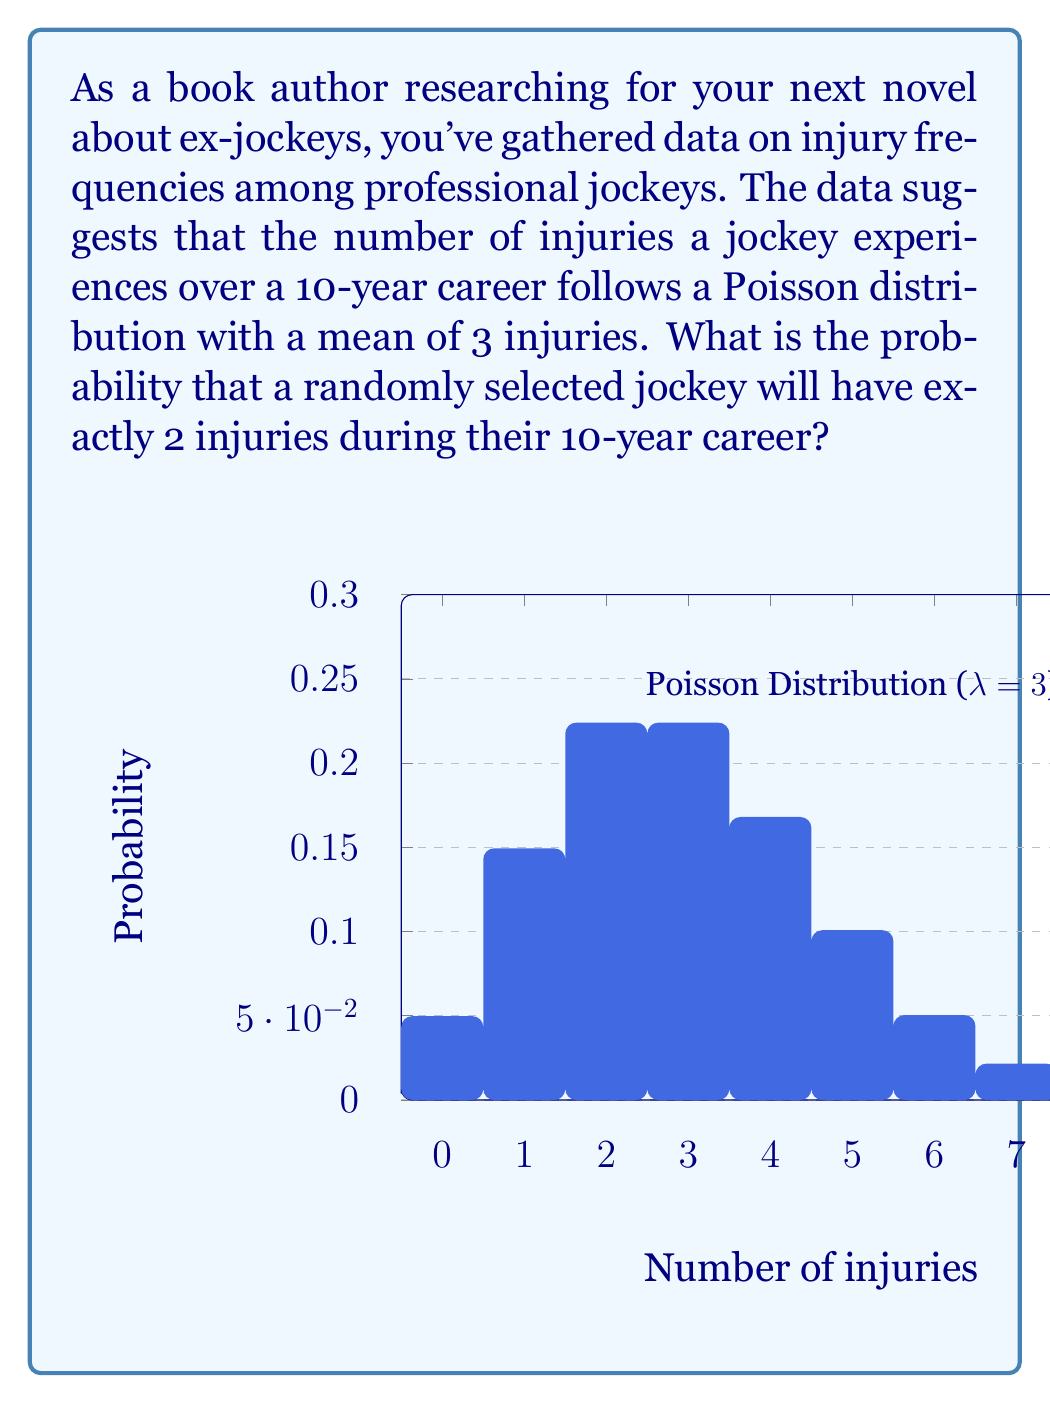Can you solve this math problem? To solve this problem, we'll use the Poisson probability mass function:

$$P(X = k) = \frac{e^{-\lambda}\lambda^k}{k!}$$

Where:
- $\lambda$ is the average number of events in the given interval (in this case, $\lambda = 3$)
- $k$ is the number of events we're interested in (in this case, $k = 2$)
- $e$ is Euler's number (approximately 2.71828)

Let's calculate step by step:

1) Substitute the values into the formula:
   $$P(X = 2) = \frac{e^{-3}3^2}{2!}$$

2) Calculate $e^{-3}$:
   $$e^{-3} \approx 0.04979$$

3) Calculate $3^2$:
   $$3^2 = 9$$

4) Calculate $2!$:
   $$2! = 2 \times 1 = 2$$

5) Put it all together:
   $$P(X = 2) = \frac{0.04979 \times 9}{2} \approx 0.2240$$

6) Convert to a percentage:
   $$0.2240 \times 100\% = 22.40\%$$

Therefore, the probability that a randomly selected jockey will have exactly 2 injuries during their 10-year career is approximately 22.40%.
Answer: 22.40% 